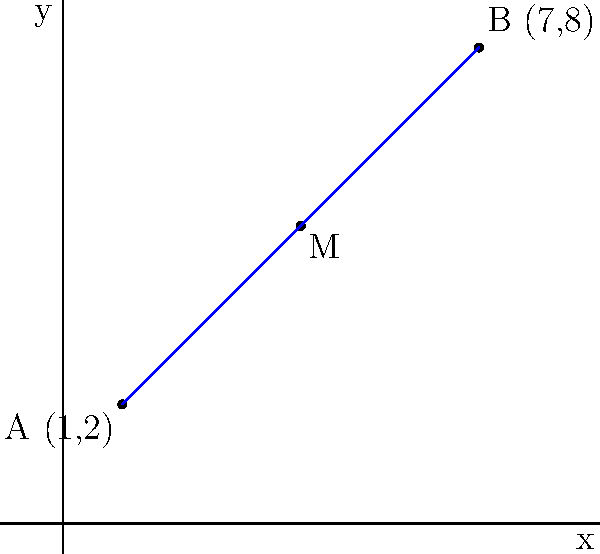As you're helping your younger sibling with their math homework, you come across a problem about coordinate geometry. To make it more interesting, you decide to relate it to planning a new hobby activity. If point A represents your current location (1,2) and point B represents the location of a new art class (7,8), what are the coordinates of point M, which is the midpoint of the line segment AB? This midpoint could be a good meeting spot for both of you. Let's approach this step-by-step:

1) The midpoint formula states that for two points $(x_1, y_1)$ and $(x_2, y_2)$, the midpoint is:

   $(\frac{x_1 + x_2}{2}, \frac{y_1 + y_2}{2})$

2) In this case:
   Point A: $(x_1, y_1) = (1, 2)$
   Point B: $(x_2, y_2) = (7, 8)$

3) Let's calculate the x-coordinate of the midpoint:
   $x = \frac{x_1 + x_2}{2} = \frac{1 + 7}{2} = \frac{8}{2} = 4$

4) Now, let's calculate the y-coordinate of the midpoint:
   $y = \frac{y_1 + y_2}{2} = \frac{2 + 8}{2} = \frac{10}{2} = 5$

5) Therefore, the coordinates of the midpoint M are (4, 5).

This point (4, 5) would be an ideal meeting spot, as it's exactly halfway between your current location and the art class location.
Answer: (4, 5) 